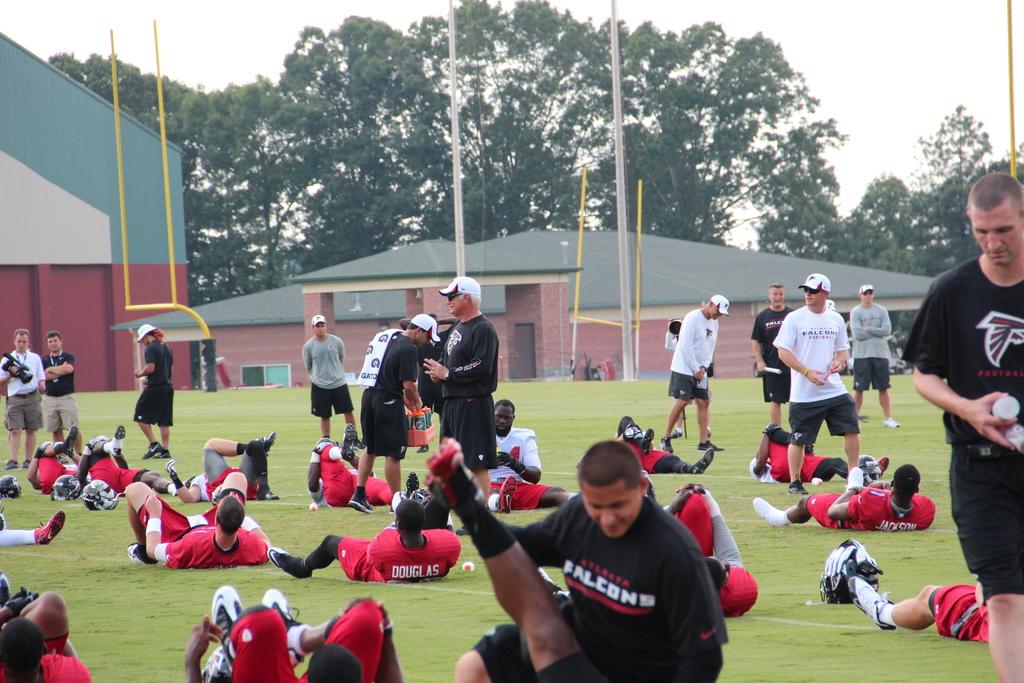What is one of the players names?
Keep it short and to the point. Douglas. What is the player's team?
Ensure brevity in your answer.  Falcons. 